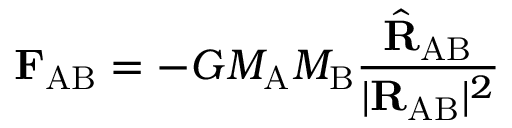Convert formula to latex. <formula><loc_0><loc_0><loc_500><loc_500>F _ { A B } = - G M _ { A } M _ { B } { \frac { { \hat { R } } _ { A B } } { | R _ { A B } | ^ { 2 } } }</formula> 